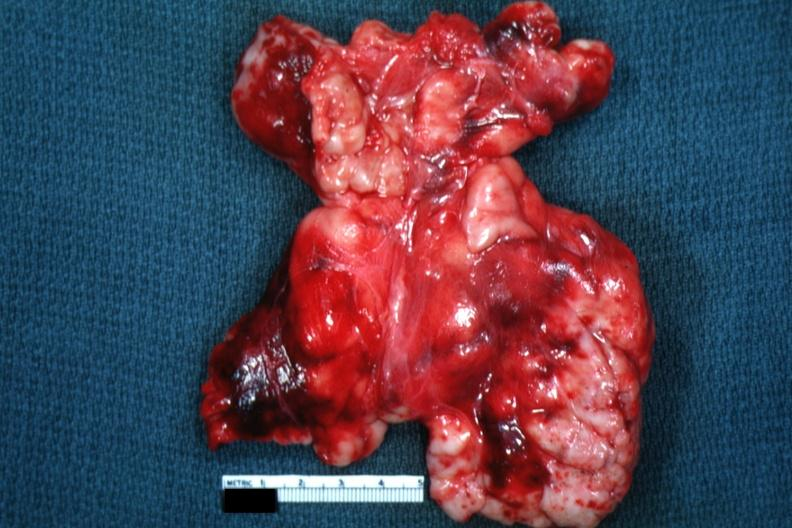where is this part in?
Answer the question using a single word or phrase. Thymus 